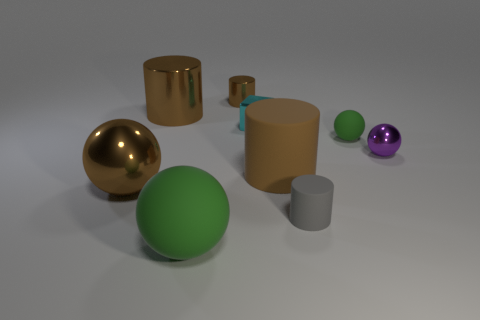Subtract all green cubes. How many brown cylinders are left? 3 Subtract all cyan spheres. Subtract all purple cubes. How many spheres are left? 4 Subtract all balls. How many objects are left? 5 Subtract all blocks. Subtract all big green matte balls. How many objects are left? 7 Add 3 large matte balls. How many large matte balls are left? 4 Add 2 small metal spheres. How many small metal spheres exist? 3 Subtract 1 green spheres. How many objects are left? 8 